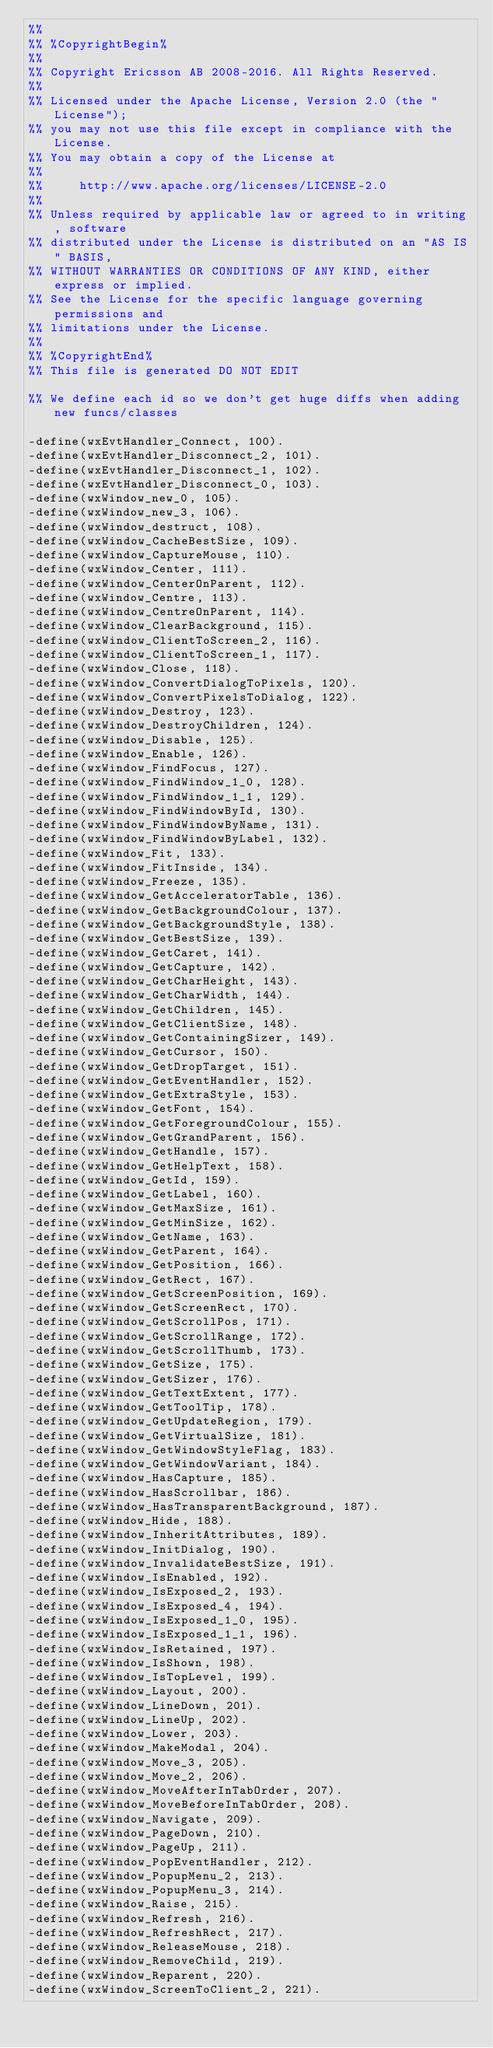Convert code to text. <code><loc_0><loc_0><loc_500><loc_500><_Erlang_>%%
%% %CopyrightBegin%
%%
%% Copyright Ericsson AB 2008-2016. All Rights Reserved.
%%
%% Licensed under the Apache License, Version 2.0 (the "License");
%% you may not use this file except in compliance with the License.
%% You may obtain a copy of the License at
%%
%%     http://www.apache.org/licenses/LICENSE-2.0
%%
%% Unless required by applicable law or agreed to in writing, software
%% distributed under the License is distributed on an "AS IS" BASIS,
%% WITHOUT WARRANTIES OR CONDITIONS OF ANY KIND, either express or implied.
%% See the License for the specific language governing permissions and
%% limitations under the License.
%%
%% %CopyrightEnd%
%% This file is generated DO NOT EDIT

%% We define each id so we don't get huge diffs when adding new funcs/classes

-define(wxEvtHandler_Connect, 100).
-define(wxEvtHandler_Disconnect_2, 101).
-define(wxEvtHandler_Disconnect_1, 102).
-define(wxEvtHandler_Disconnect_0, 103).
-define(wxWindow_new_0, 105).
-define(wxWindow_new_3, 106).
-define(wxWindow_destruct, 108).
-define(wxWindow_CacheBestSize, 109).
-define(wxWindow_CaptureMouse, 110).
-define(wxWindow_Center, 111).
-define(wxWindow_CenterOnParent, 112).
-define(wxWindow_Centre, 113).
-define(wxWindow_CentreOnParent, 114).
-define(wxWindow_ClearBackground, 115).
-define(wxWindow_ClientToScreen_2, 116).
-define(wxWindow_ClientToScreen_1, 117).
-define(wxWindow_Close, 118).
-define(wxWindow_ConvertDialogToPixels, 120).
-define(wxWindow_ConvertPixelsToDialog, 122).
-define(wxWindow_Destroy, 123).
-define(wxWindow_DestroyChildren, 124).
-define(wxWindow_Disable, 125).
-define(wxWindow_Enable, 126).
-define(wxWindow_FindFocus, 127).
-define(wxWindow_FindWindow_1_0, 128).
-define(wxWindow_FindWindow_1_1, 129).
-define(wxWindow_FindWindowById, 130).
-define(wxWindow_FindWindowByName, 131).
-define(wxWindow_FindWindowByLabel, 132).
-define(wxWindow_Fit, 133).
-define(wxWindow_FitInside, 134).
-define(wxWindow_Freeze, 135).
-define(wxWindow_GetAcceleratorTable, 136).
-define(wxWindow_GetBackgroundColour, 137).
-define(wxWindow_GetBackgroundStyle, 138).
-define(wxWindow_GetBestSize, 139).
-define(wxWindow_GetCaret, 141).
-define(wxWindow_GetCapture, 142).
-define(wxWindow_GetCharHeight, 143).
-define(wxWindow_GetCharWidth, 144).
-define(wxWindow_GetChildren, 145).
-define(wxWindow_GetClientSize, 148).
-define(wxWindow_GetContainingSizer, 149).
-define(wxWindow_GetCursor, 150).
-define(wxWindow_GetDropTarget, 151).
-define(wxWindow_GetEventHandler, 152).
-define(wxWindow_GetExtraStyle, 153).
-define(wxWindow_GetFont, 154).
-define(wxWindow_GetForegroundColour, 155).
-define(wxWindow_GetGrandParent, 156).
-define(wxWindow_GetHandle, 157).
-define(wxWindow_GetHelpText, 158).
-define(wxWindow_GetId, 159).
-define(wxWindow_GetLabel, 160).
-define(wxWindow_GetMaxSize, 161).
-define(wxWindow_GetMinSize, 162).
-define(wxWindow_GetName, 163).
-define(wxWindow_GetParent, 164).
-define(wxWindow_GetPosition, 166).
-define(wxWindow_GetRect, 167).
-define(wxWindow_GetScreenPosition, 169).
-define(wxWindow_GetScreenRect, 170).
-define(wxWindow_GetScrollPos, 171).
-define(wxWindow_GetScrollRange, 172).
-define(wxWindow_GetScrollThumb, 173).
-define(wxWindow_GetSize, 175).
-define(wxWindow_GetSizer, 176).
-define(wxWindow_GetTextExtent, 177).
-define(wxWindow_GetToolTip, 178).
-define(wxWindow_GetUpdateRegion, 179).
-define(wxWindow_GetVirtualSize, 181).
-define(wxWindow_GetWindowStyleFlag, 183).
-define(wxWindow_GetWindowVariant, 184).
-define(wxWindow_HasCapture, 185).
-define(wxWindow_HasScrollbar, 186).
-define(wxWindow_HasTransparentBackground, 187).
-define(wxWindow_Hide, 188).
-define(wxWindow_InheritAttributes, 189).
-define(wxWindow_InitDialog, 190).
-define(wxWindow_InvalidateBestSize, 191).
-define(wxWindow_IsEnabled, 192).
-define(wxWindow_IsExposed_2, 193).
-define(wxWindow_IsExposed_4, 194).
-define(wxWindow_IsExposed_1_0, 195).
-define(wxWindow_IsExposed_1_1, 196).
-define(wxWindow_IsRetained, 197).
-define(wxWindow_IsShown, 198).
-define(wxWindow_IsTopLevel, 199).
-define(wxWindow_Layout, 200).
-define(wxWindow_LineDown, 201).
-define(wxWindow_LineUp, 202).
-define(wxWindow_Lower, 203).
-define(wxWindow_MakeModal, 204).
-define(wxWindow_Move_3, 205).
-define(wxWindow_Move_2, 206).
-define(wxWindow_MoveAfterInTabOrder, 207).
-define(wxWindow_MoveBeforeInTabOrder, 208).
-define(wxWindow_Navigate, 209).
-define(wxWindow_PageDown, 210).
-define(wxWindow_PageUp, 211).
-define(wxWindow_PopEventHandler, 212).
-define(wxWindow_PopupMenu_2, 213).
-define(wxWindow_PopupMenu_3, 214).
-define(wxWindow_Raise, 215).
-define(wxWindow_Refresh, 216).
-define(wxWindow_RefreshRect, 217).
-define(wxWindow_ReleaseMouse, 218).
-define(wxWindow_RemoveChild, 219).
-define(wxWindow_Reparent, 220).
-define(wxWindow_ScreenToClient_2, 221).</code> 